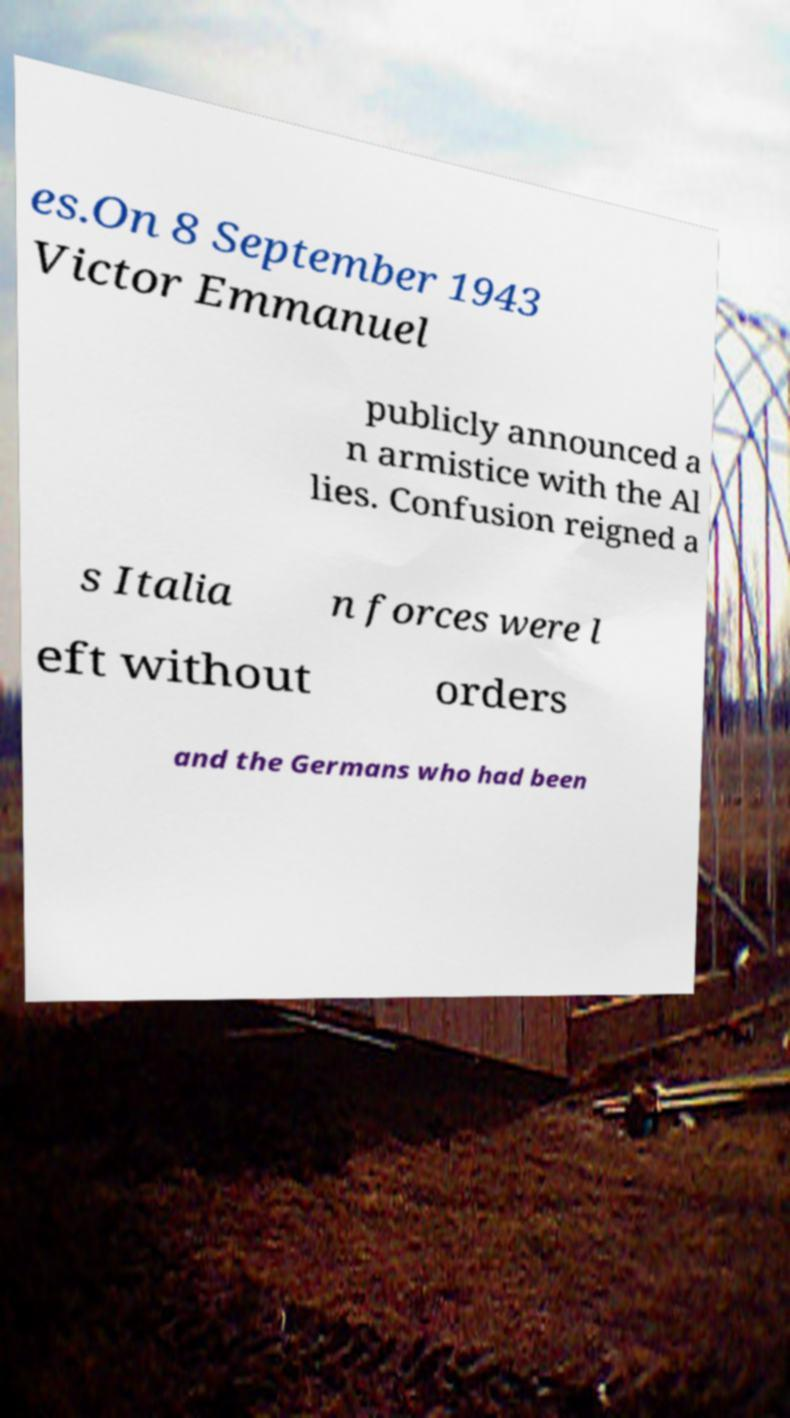Please read and relay the text visible in this image. What does it say? es.On 8 September 1943 Victor Emmanuel publicly announced a n armistice with the Al lies. Confusion reigned a s Italia n forces were l eft without orders and the Germans who had been 